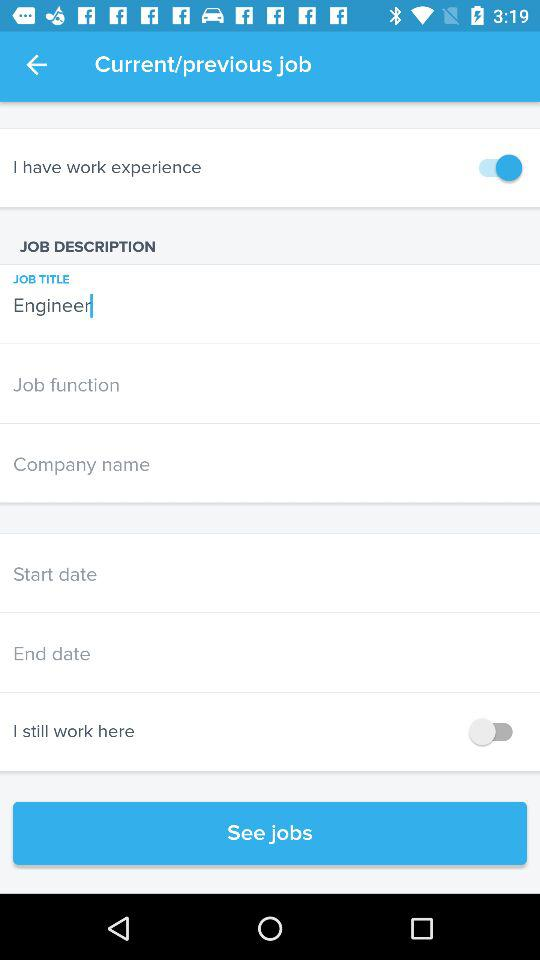How many more input fields are there for the company name than for the job function?
Answer the question using a single word or phrase. 1 